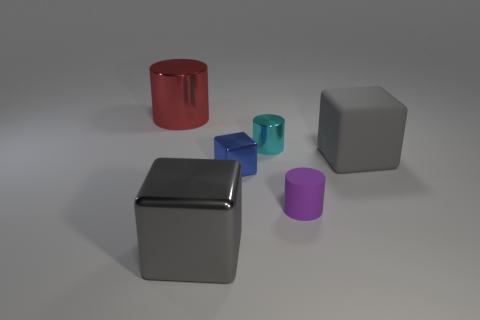Do the cylinder in front of the blue object and the red thing have the same size?
Provide a short and direct response. No. Are there more tiny matte cylinders that are to the right of the tiny rubber object than cyan metal cylinders?
Offer a very short reply. No. Is the tiny cyan object the same shape as the small blue object?
Provide a short and direct response. No. What is the size of the red shiny cylinder?
Make the answer very short. Large. Is the number of small blocks that are to the right of the small cyan thing greater than the number of cyan metal cylinders right of the tiny purple cylinder?
Provide a succinct answer. No. Are there any rubber blocks behind the cyan metallic cylinder?
Your response must be concise. No. Are there any gray objects of the same size as the blue shiny block?
Your response must be concise. No. The other large cube that is the same material as the blue block is what color?
Keep it short and to the point. Gray. What is the blue thing made of?
Keep it short and to the point. Metal. What shape is the large gray metallic object?
Your response must be concise. Cube. 